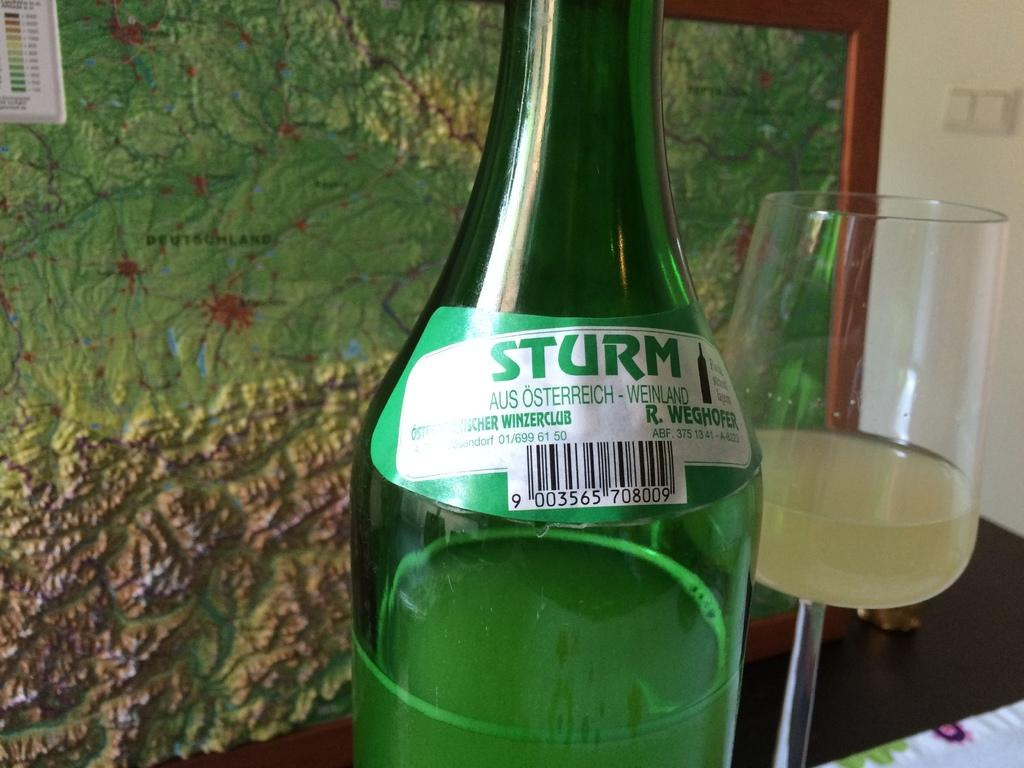Provide a one-sentence caption for the provided image. A bottle of Sturm wine from winerzclub sits on a table in front of a map. 